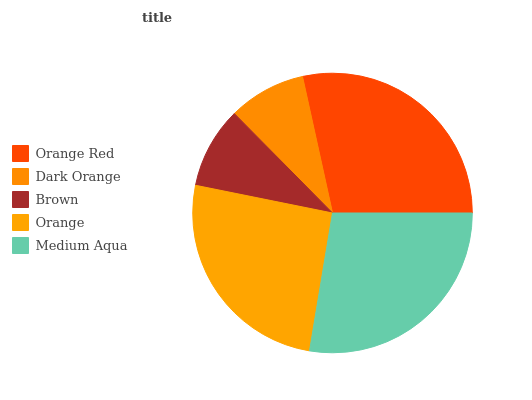Is Dark Orange the minimum?
Answer yes or no. Yes. Is Orange Red the maximum?
Answer yes or no. Yes. Is Brown the minimum?
Answer yes or no. No. Is Brown the maximum?
Answer yes or no. No. Is Brown greater than Dark Orange?
Answer yes or no. Yes. Is Dark Orange less than Brown?
Answer yes or no. Yes. Is Dark Orange greater than Brown?
Answer yes or no. No. Is Brown less than Dark Orange?
Answer yes or no. No. Is Orange the high median?
Answer yes or no. Yes. Is Orange the low median?
Answer yes or no. Yes. Is Orange Red the high median?
Answer yes or no. No. Is Medium Aqua the low median?
Answer yes or no. No. 